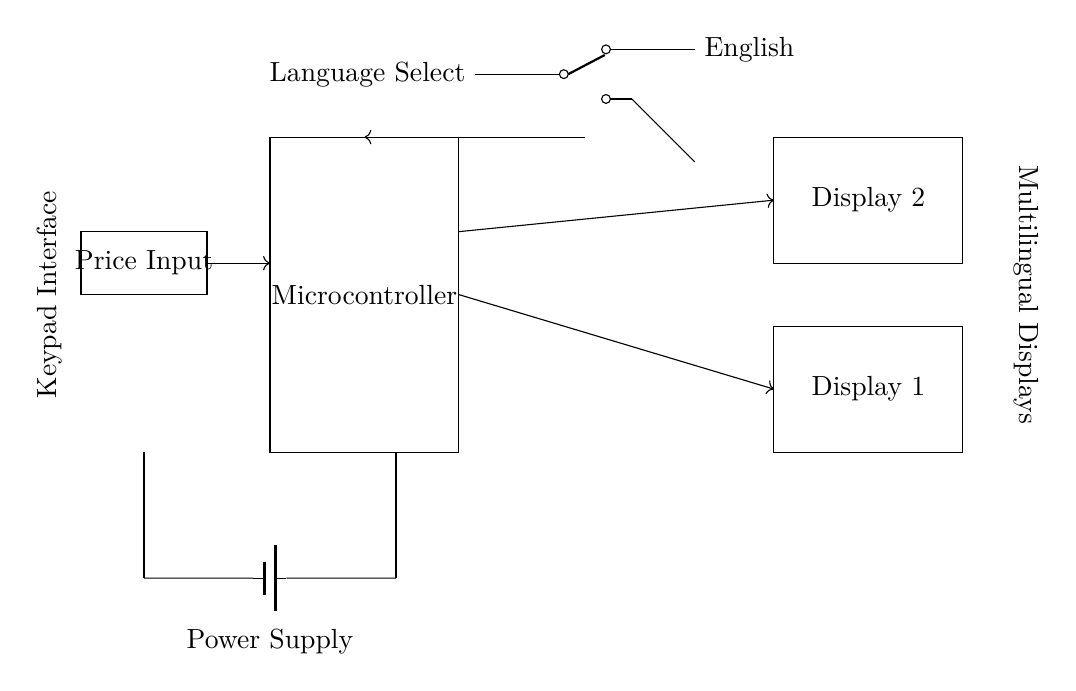What are the two languages supported by the display? The two languages are English and Thai, indicated by the labels next to the language selector switch in the circuit diagram.
Answer: English, Thai What is the function of the microcontroller in this circuit? The microcontroller manages the display output based on the selected language and processes input from the price input. Its role is to control the logic and flow of data within the circuit.
Answer: Control How many displays are present in the circuit? There are two display units in the circuit, as shown by the two rectangles labeled "Display 1" and "Display 2."
Answer: Two What component connects the language selector to the microcontroller? The language selector switch connects directly to the microcontroller, allowing it to process the language selection for the display outputs.
Answer: Switch What type of input is required for the price? The price input requires a numeric value, as indicated by the "Price Input" component in the circuit diagram. This component is where the shopkeeper would enter the price of the item.
Answer: Numeric What type of power supply is used in the circuit? The circuit uses a battery as a power supply, identified by the symbol for a battery in the lower section of the circuit diagram.
Answer: Battery How does the price input relate to the displays? The price input provides data that is sent from the microcontroller to the displays, determining what price information is shown based on the selected language.
Answer: Data flow 